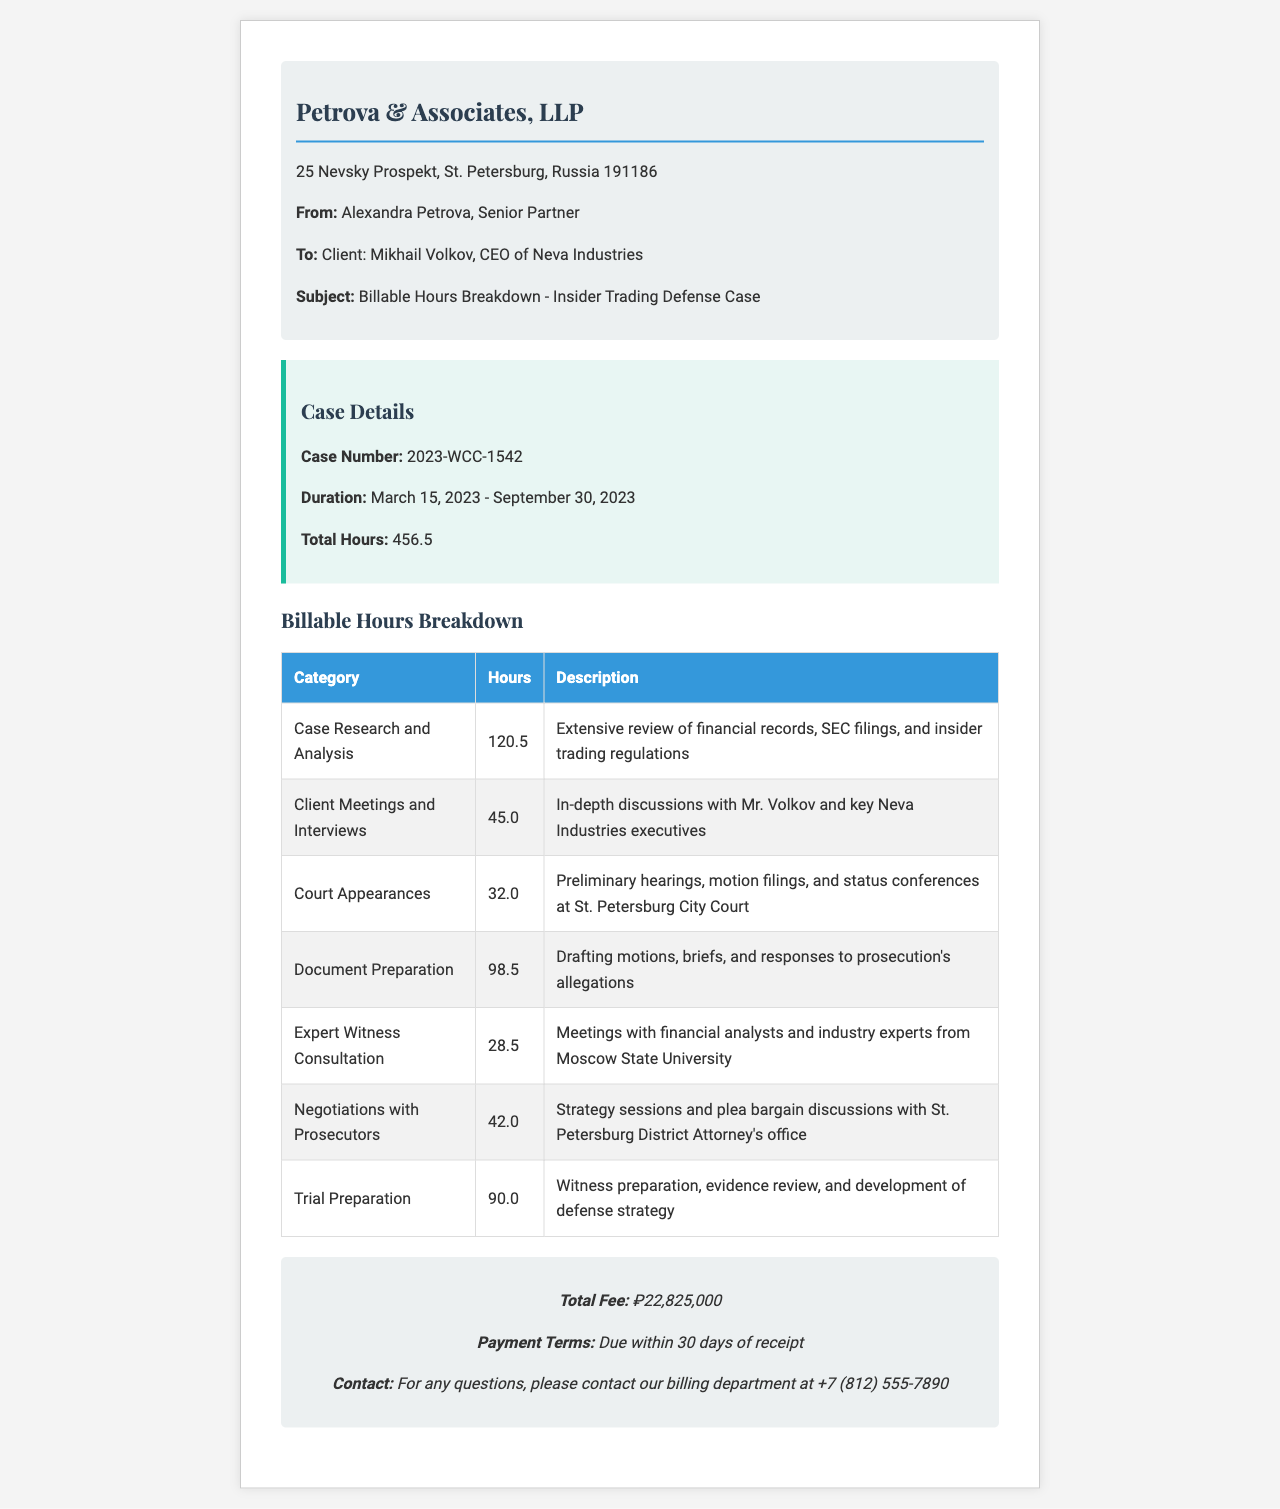what is the case number? The case number is specified in the case details section of the document, indicating the unique identifier for the case.
Answer: 2023-WCC-1542 who is the recipient of the fax? The recipient is noted in the header section, identifying the individual or entity that the document is addressed to.
Answer: Mikhail Volkov how many total hours were billed? The total hours are summarized in the case details, representing the overall time spent on the case.
Answer: 456.5 what is the fee for the services rendered? The total fee is provided in the footer of the document, summarizing the financial aspect of the billing.
Answer: ₽22,825,000 which category had the highest billable hours? This question requires analyzing the breakdown table to identify the category with the most hours logged.
Answer: Case Research and Analysis how many hours were spent on expert witness consultation? This asks for a specific value from the billing hours breakdown focusing on consultations with experts.
Answer: 28.5 what was the duration of the case? The duration provides the timeframe of the case, essential for understanding the context of the billable hours.
Answer: March 15, 2023 - September 30, 2023 what are the payment terms? The payment terms outline the conditions under which the payment is expected to be made.
Answer: Due within 30 days of receipt how many hours were dedicated to trial preparation? This question looks for specific insights into the preparation phase, which is detailed in the breakdown.
Answer: 90.0 